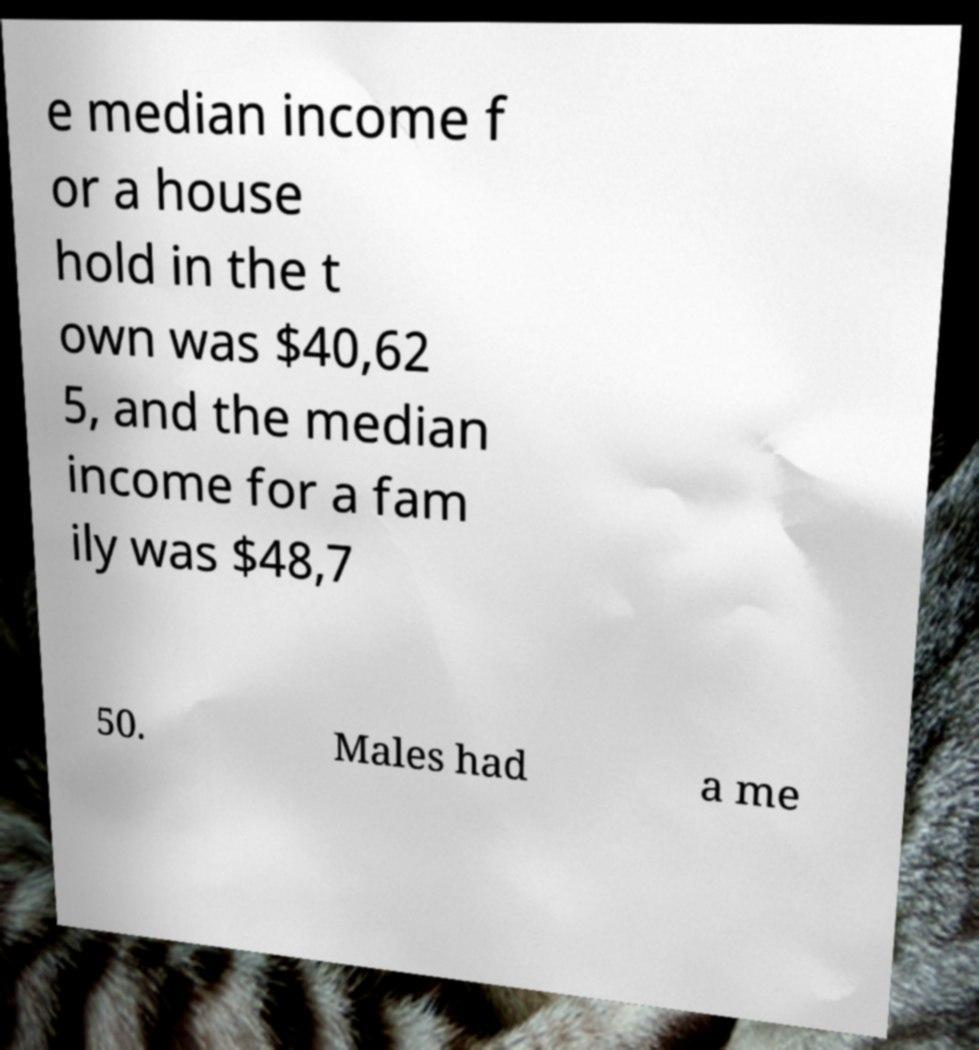Can you read and provide the text displayed in the image?This photo seems to have some interesting text. Can you extract and type it out for me? e median income f or a house hold in the t own was $40,62 5, and the median income for a fam ily was $48,7 50. Males had a me 